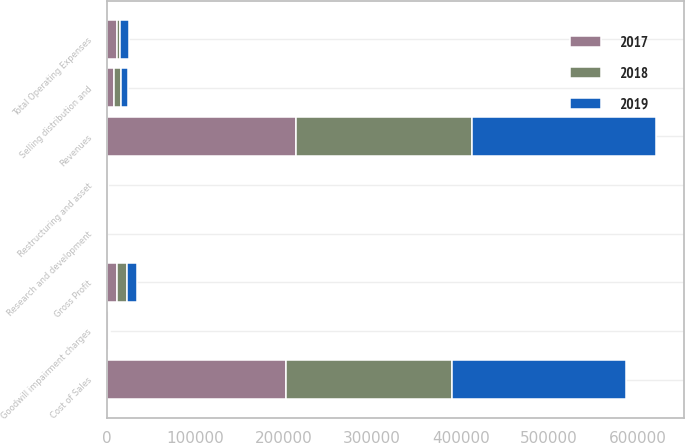Convert chart. <chart><loc_0><loc_0><loc_500><loc_500><stacked_bar_chart><ecel><fcel>Revenues<fcel>Cost of Sales<fcel>Gross Profit<fcel>Selling distribution and<fcel>Research and development<fcel>Goodwill impairment charges<fcel>Restructuring and asset<fcel>Total Operating Expenses<nl><fcel>2017<fcel>214319<fcel>202565<fcel>11754<fcel>8403<fcel>71<fcel>1797<fcel>597<fcel>10868<nl><fcel>2019<fcel>208357<fcel>197173<fcel>11184<fcel>8138<fcel>125<fcel>1738<fcel>567<fcel>10422<nl><fcel>2018<fcel>198533<fcel>187262<fcel>11271<fcel>7447<fcel>341<fcel>290<fcel>18<fcel>4149<nl></chart> 